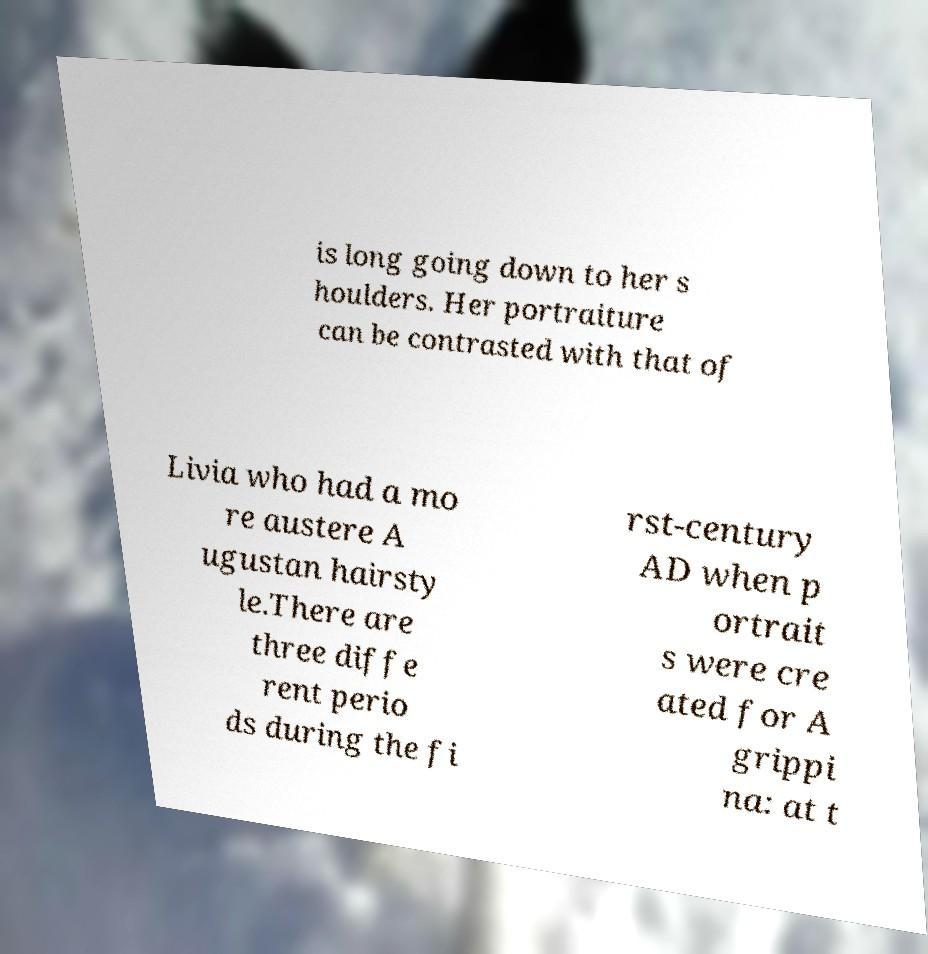Could you assist in decoding the text presented in this image and type it out clearly? is long going down to her s houlders. Her portraiture can be contrasted with that of Livia who had a mo re austere A ugustan hairsty le.There are three diffe rent perio ds during the fi rst-century AD when p ortrait s were cre ated for A grippi na: at t 